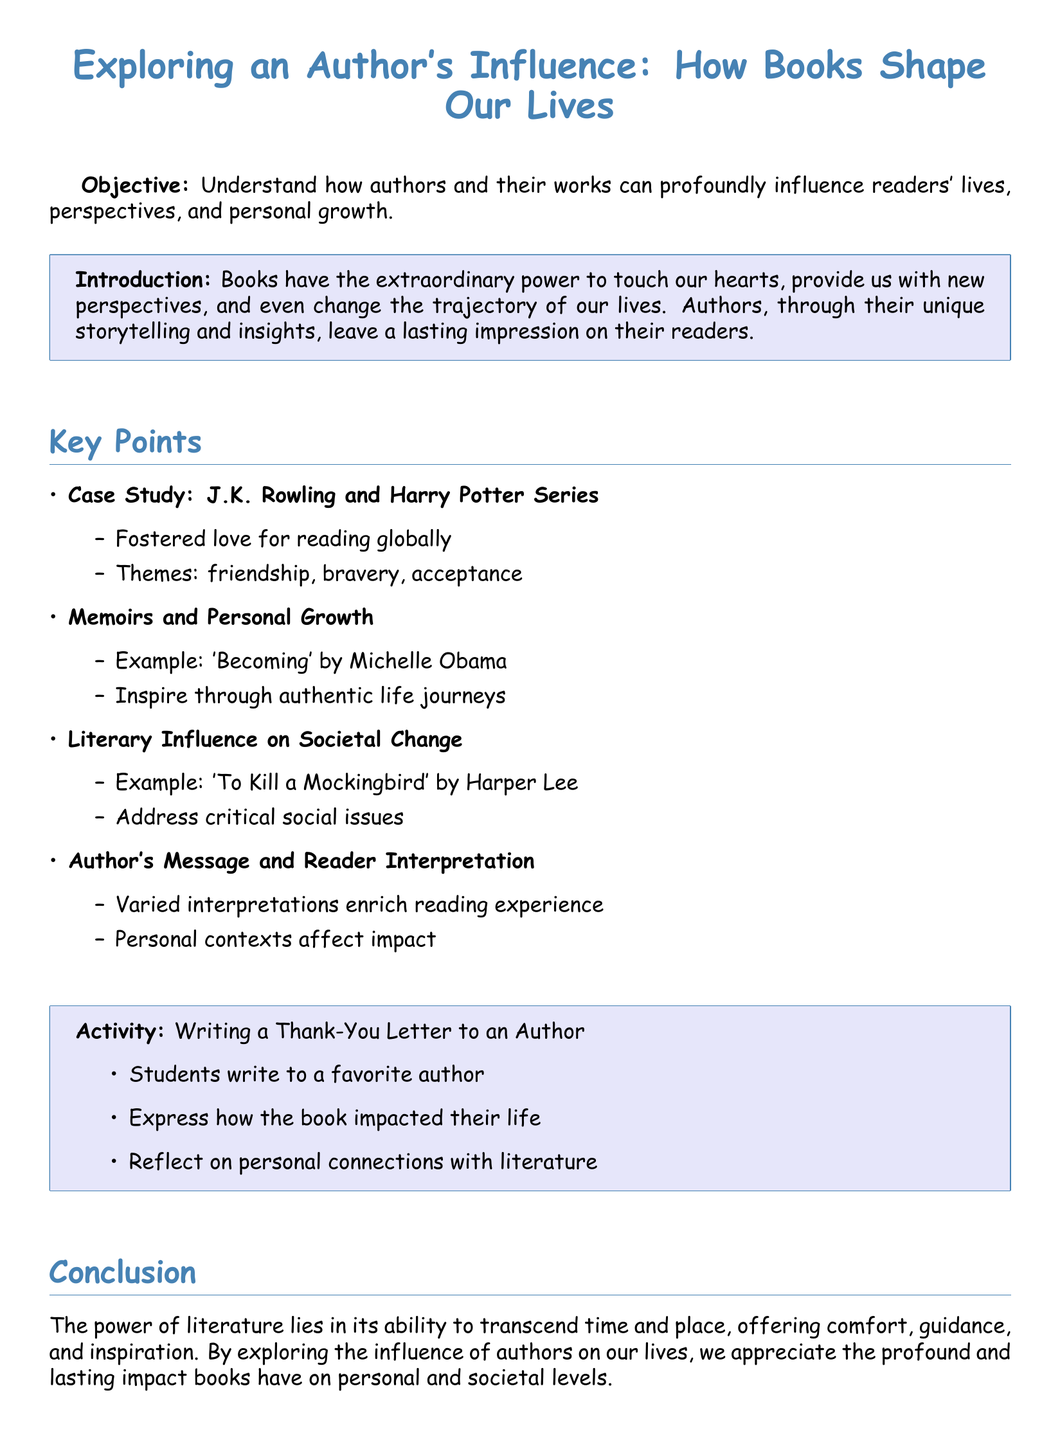What is the title of the lesson plan? The title of the lesson plan is the main heading of the document that describes its focus.
Answer: Exploring an Author's Influence: How Books Shape Our Lives Who is used as a case study in the lesson plan? The case study highlighted in the lesson plan exemplifies an author's significant impact through their work.
Answer: J.K. Rowling Name one theme of the Harry Potter series mentioned in the lesson plan. The lesson plan lists themes associated with the Harry Potter series that illustrate its broader impacts on readers.
Answer: Friendship Which memoir is mentioned as an example of personal growth? The lesson plan includes a memoir that serves as an illustration of authentic life journeys and their inspirational value.
Answer: Becoming What type of activity do students perform in the lesson plan? The activity described in the lesson plan involves a creative exercise that encourages students to connect personally with literature.
Answer: Writing a Thank-You Letter to an Author What critical social issue is addressed in 'To Kill a Mockingbird'? The lesson plan references a notable literary work that engages with essential societal concerns.
Answer: Critical social issues How does the document classify the author's message and reader interpretation? The document explains the dynamic relationship between an author's intent and how readers perceive the message within a literary context.
Answer: Varied interpretations enrich reading experience What is the main objective of the lesson plan? The objective summarizes the primary aim of the lesson plan regarding readers' relationships with literature.
Answer: Understand how authors and their works can profoundly influence readers' lives 